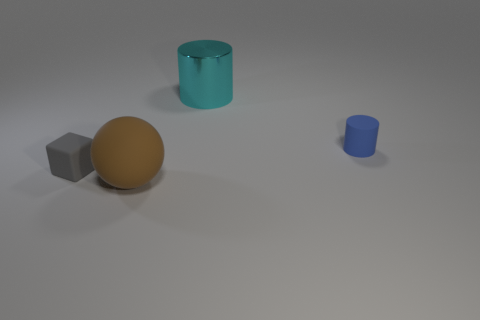Subtract all purple balls. Subtract all blue blocks. How many balls are left? 1 Add 3 tiny yellow spheres. How many objects exist? 7 Subtract all balls. How many objects are left? 3 Add 1 blue shiny spheres. How many blue shiny spheres exist? 1 Subtract 0 red balls. How many objects are left? 4 Subtract all tiny gray matte objects. Subtract all large red metallic cylinders. How many objects are left? 3 Add 2 large rubber objects. How many large rubber objects are left? 3 